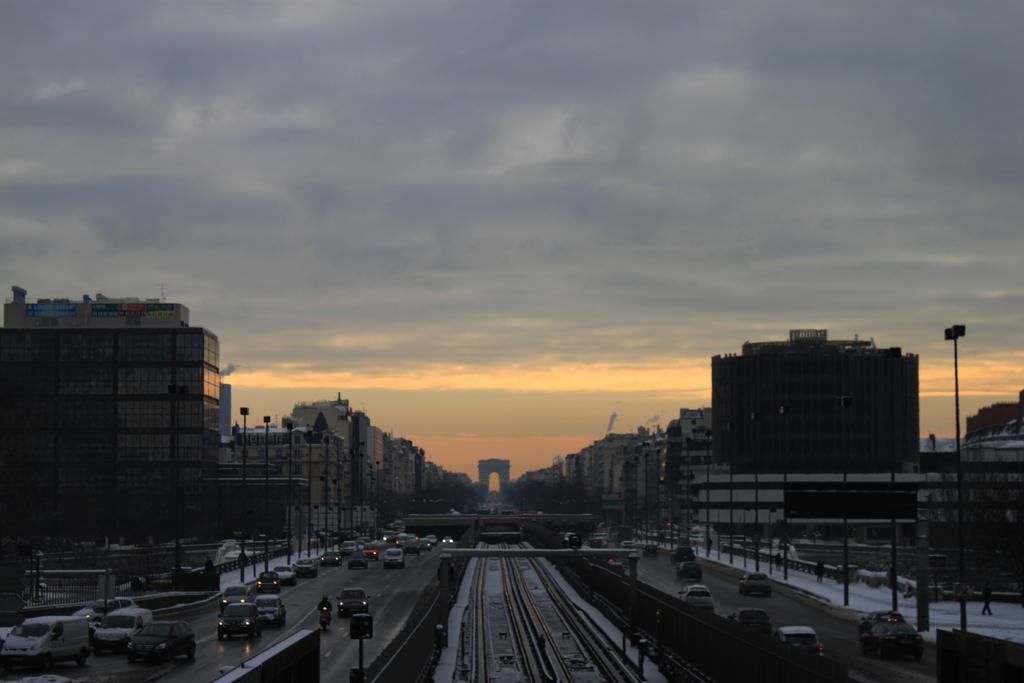Please provide a concise description of this image. In this image we can see many buildings and vehicles. There are few people in the image. There is a snow in the image. There is a fence at the left side of the image. There is a cloudy sky in the image. There are many street lights in the image. There are railway tracks in the image. 